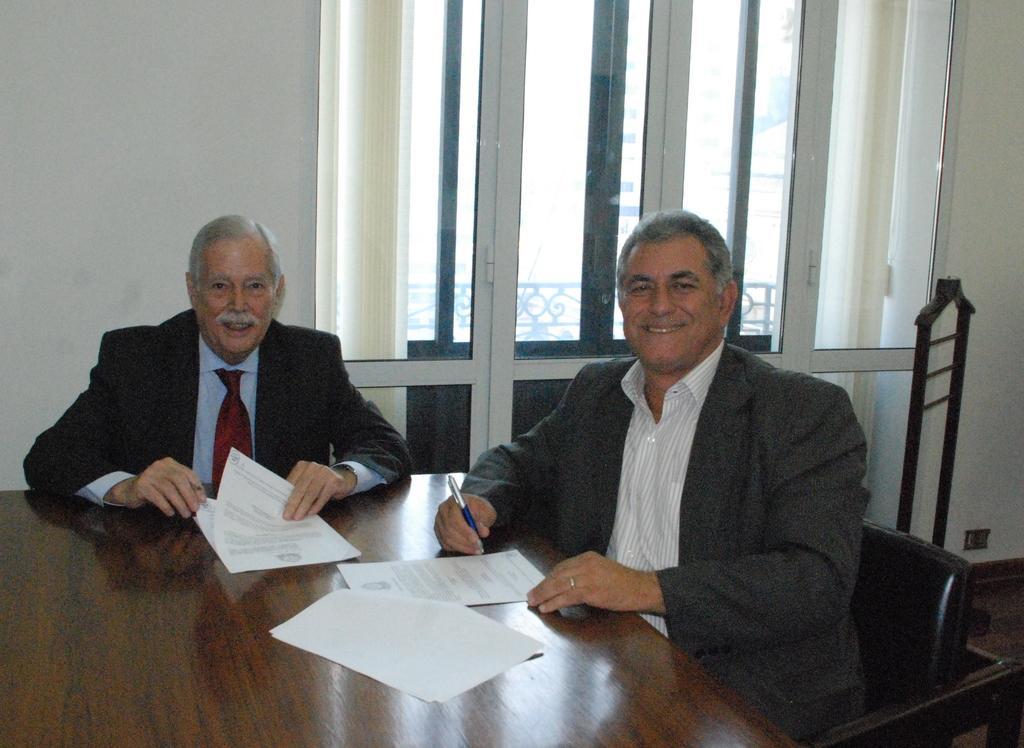How would you summarize this image in a sentence or two? In this image I can see two men are sitting on chairs. I can also see smile on their faces. On this table I can see few papers and he is holding a pen. 